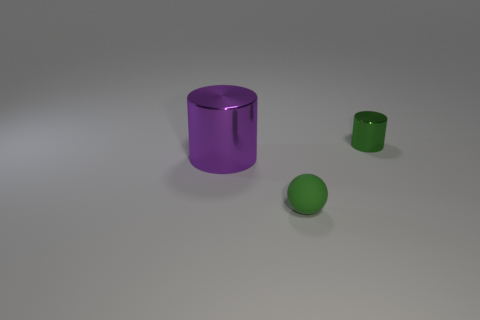Add 3 tiny red rubber things. How many objects exist? 6 Subtract all balls. How many objects are left? 2 Subtract all small green things. Subtract all tiny green rubber objects. How many objects are left? 0 Add 1 big purple things. How many big purple things are left? 2 Add 2 small purple blocks. How many small purple blocks exist? 2 Subtract 0 cyan cubes. How many objects are left? 3 